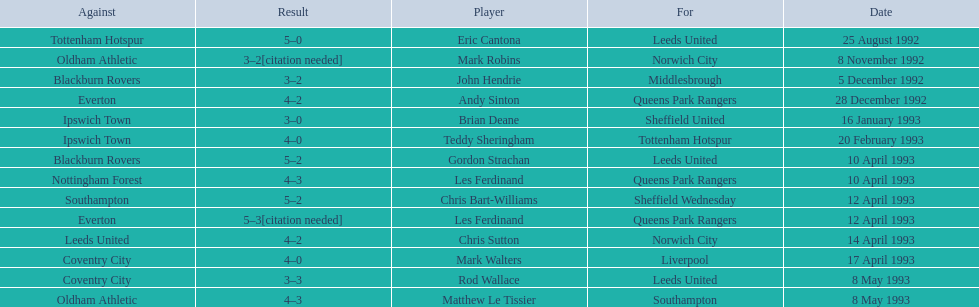Who are the players in 1992-93 fa premier league? Eric Cantona, Mark Robins, John Hendrie, Andy Sinton, Brian Deane, Teddy Sheringham, Gordon Strachan, Les Ferdinand, Chris Bart-Williams, Les Ferdinand, Chris Sutton, Mark Walters, Rod Wallace, Matthew Le Tissier. What is mark robins' result? 3–2[citation needed]. Which player has the same result? John Hendrie. 